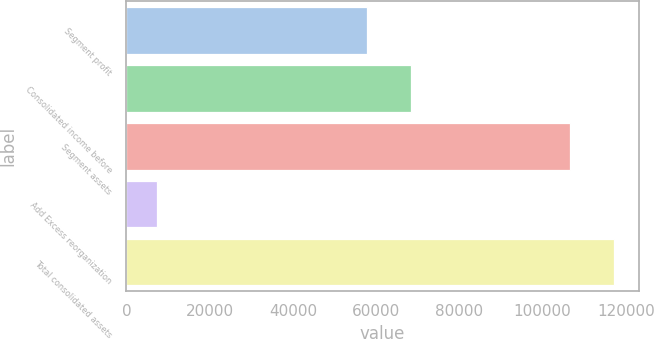Convert chart to OTSL. <chart><loc_0><loc_0><loc_500><loc_500><bar_chart><fcel>Segment profit<fcel>Consolidated income before<fcel>Segment assets<fcel>Add Excess reorganization<fcel>Total consolidated assets<nl><fcel>57754<fcel>68408.2<fcel>106542<fcel>7347<fcel>117196<nl></chart> 